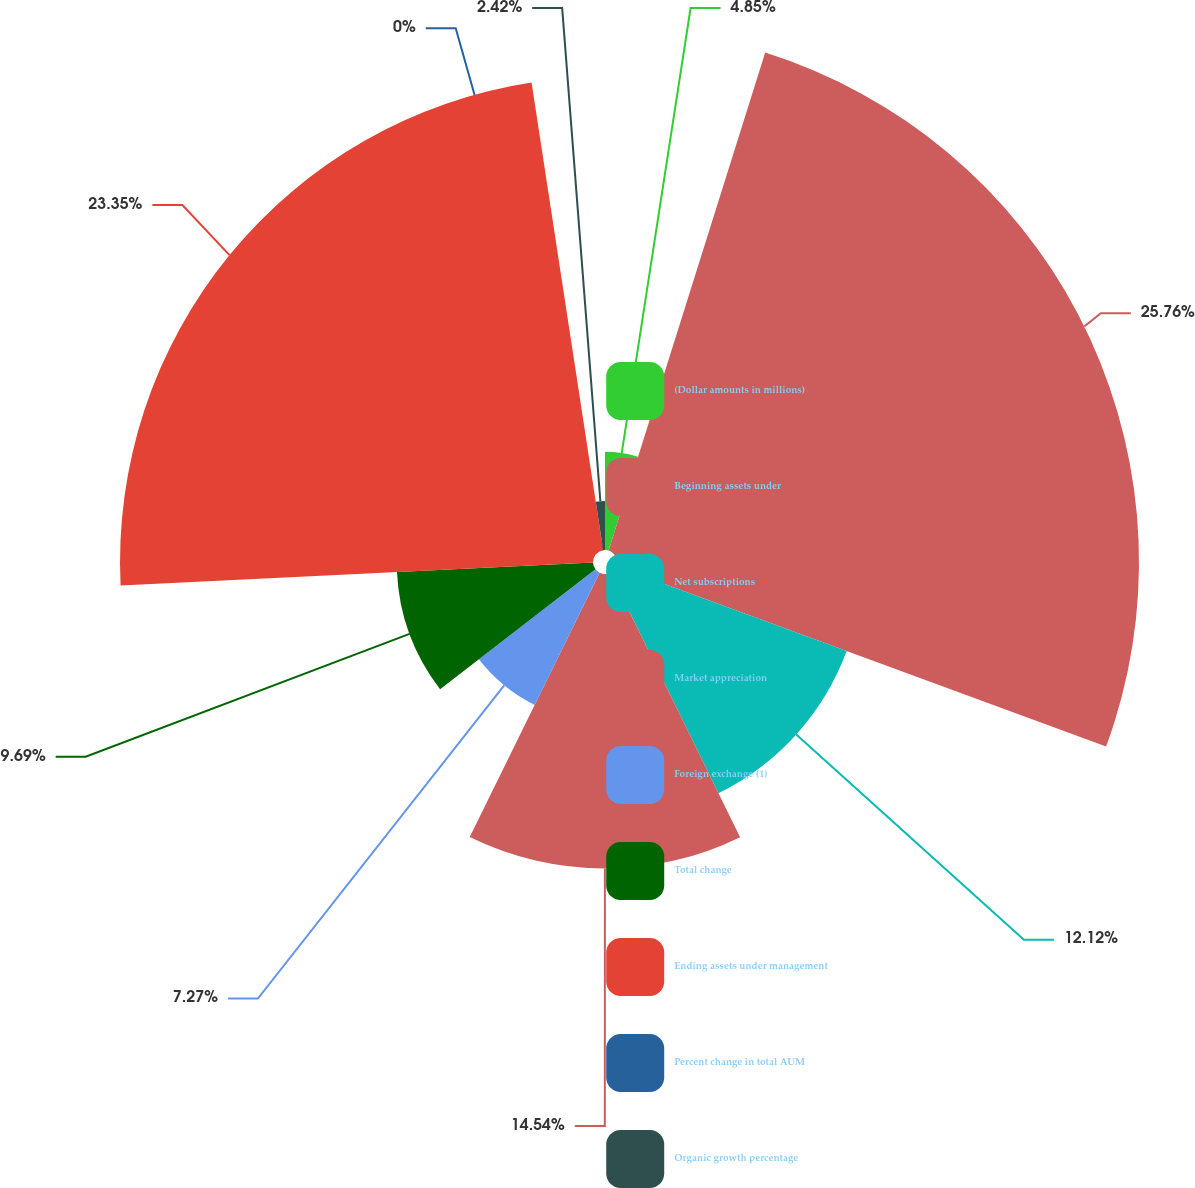<chart> <loc_0><loc_0><loc_500><loc_500><pie_chart><fcel>(Dollar amounts in millions)<fcel>Beginning assets under<fcel>Net subscriptions<fcel>Market appreciation<fcel>Foreign exchange (1)<fcel>Total change<fcel>Ending assets under management<fcel>Percent change in total AUM<fcel>Organic growth percentage<nl><fcel>4.85%<fcel>25.77%<fcel>12.12%<fcel>14.54%<fcel>7.27%<fcel>9.69%<fcel>23.35%<fcel>0.0%<fcel>2.42%<nl></chart> 